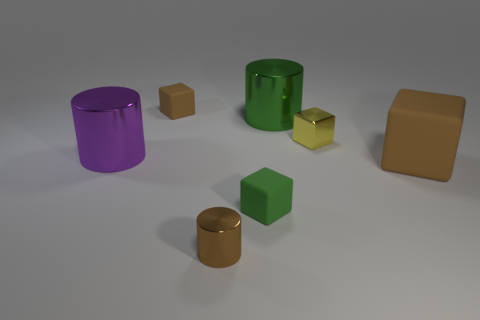There is a metallic cylinder that is the same color as the big cube; what size is it?
Provide a succinct answer. Small. What is the shape of the large object that is the same color as the tiny shiny cylinder?
Give a very brief answer. Cube. How many objects are either objects that are on the left side of the small brown block or tiny yellow shiny objects that are on the right side of the tiny brown block?
Provide a short and direct response. 2. Does the tiny brown object that is right of the tiny brown rubber thing have the same material as the green object that is in front of the purple cylinder?
Give a very brief answer. No. There is a small brown object that is in front of the big green shiny cylinder that is on the right side of the green cube; what is its shape?
Provide a short and direct response. Cylinder. Are there any other things that are the same color as the big matte thing?
Offer a terse response. Yes. Are there any metallic cylinders that are to the right of the tiny rubber block that is behind the purple metallic cylinder on the left side of the large brown rubber cube?
Provide a short and direct response. Yes. There is a small rubber cube that is to the left of the tiny metallic cylinder; does it have the same color as the large rubber object behind the tiny brown shiny thing?
Your answer should be very brief. Yes. There is a brown cube that is the same size as the yellow cube; what material is it?
Give a very brief answer. Rubber. What size is the brown thing behind the large green metallic cylinder behind the big shiny cylinder on the left side of the tiny brown cube?
Ensure brevity in your answer.  Small. 